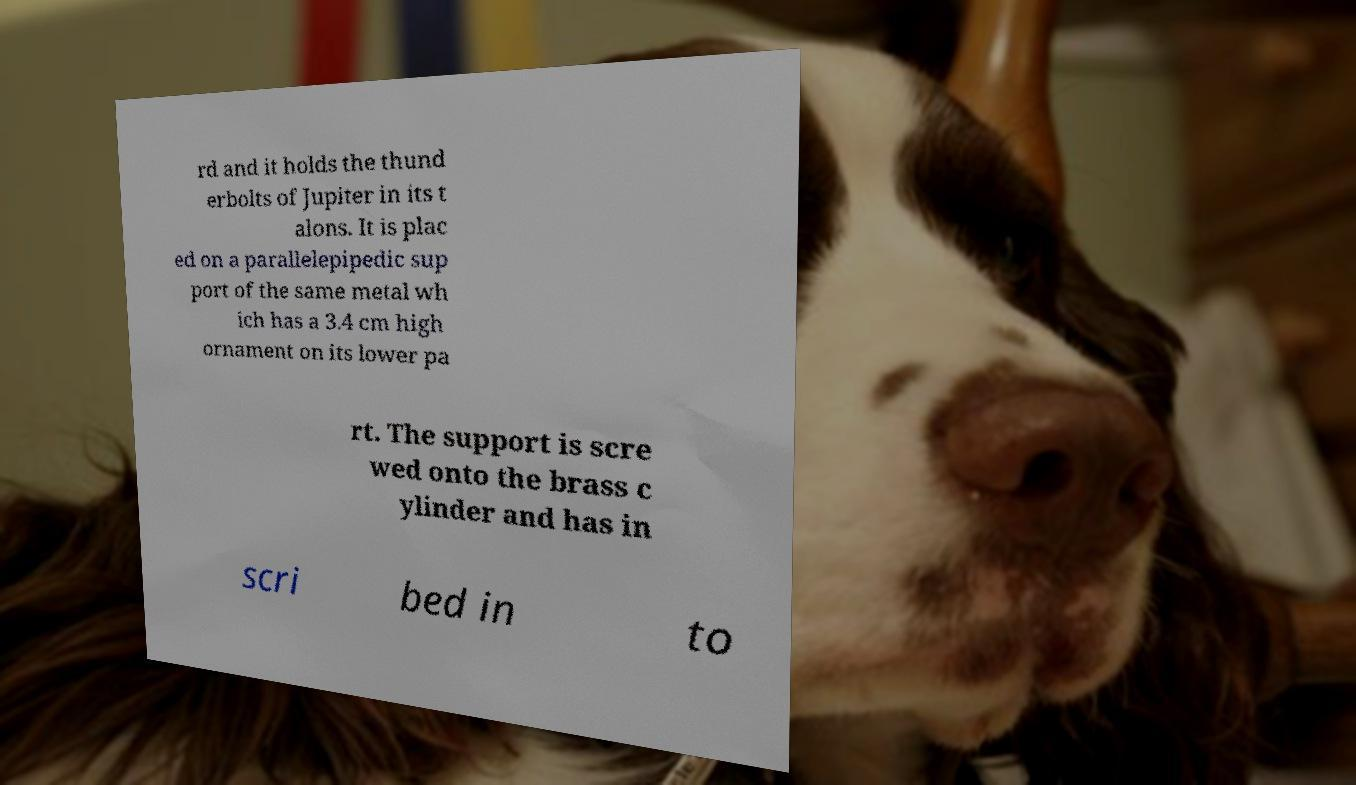Could you extract and type out the text from this image? rd and it holds the thund erbolts of Jupiter in its t alons. It is plac ed on a parallelepipedic sup port of the same metal wh ich has a 3.4 cm high ornament on its lower pa rt. The support is scre wed onto the brass c ylinder and has in scri bed in to 